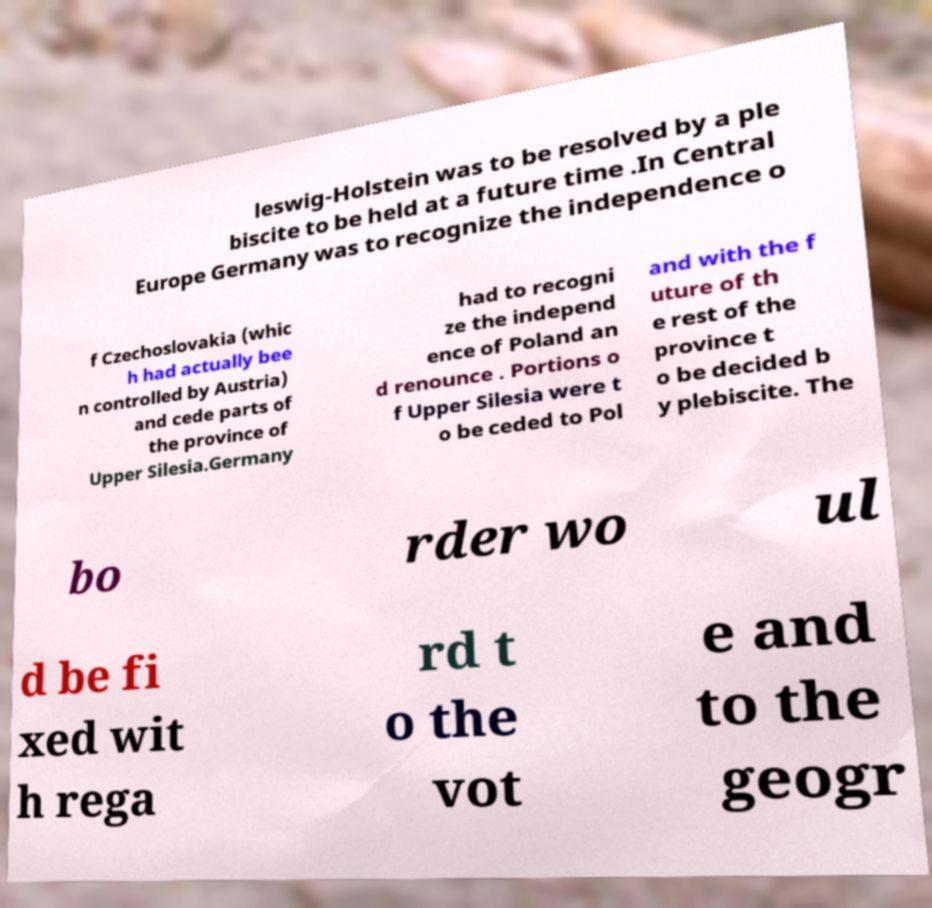I need the written content from this picture converted into text. Can you do that? leswig-Holstein was to be resolved by a ple biscite to be held at a future time .In Central Europe Germany was to recognize the independence o f Czechoslovakia (whic h had actually bee n controlled by Austria) and cede parts of the province of Upper Silesia.Germany had to recogni ze the independ ence of Poland an d renounce . Portions o f Upper Silesia were t o be ceded to Pol and with the f uture of th e rest of the province t o be decided b y plebiscite. The bo rder wo ul d be fi xed wit h rega rd t o the vot e and to the geogr 